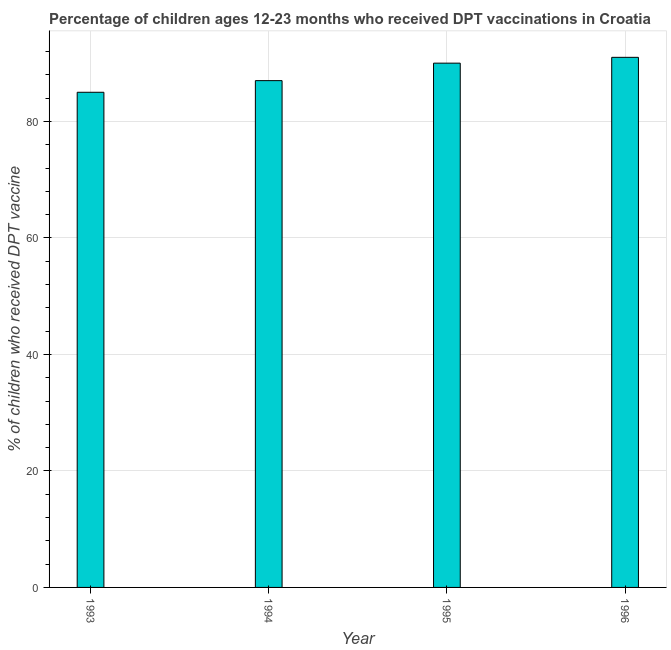Does the graph contain any zero values?
Your answer should be very brief. No. What is the title of the graph?
Provide a short and direct response. Percentage of children ages 12-23 months who received DPT vaccinations in Croatia. What is the label or title of the Y-axis?
Provide a short and direct response. % of children who received DPT vaccine. Across all years, what is the maximum percentage of children who received dpt vaccine?
Offer a terse response. 91. In which year was the percentage of children who received dpt vaccine maximum?
Offer a terse response. 1996. In which year was the percentage of children who received dpt vaccine minimum?
Ensure brevity in your answer.  1993. What is the sum of the percentage of children who received dpt vaccine?
Offer a terse response. 353. What is the average percentage of children who received dpt vaccine per year?
Give a very brief answer. 88. What is the median percentage of children who received dpt vaccine?
Provide a short and direct response. 88.5. In how many years, is the percentage of children who received dpt vaccine greater than 24 %?
Keep it short and to the point. 4. What is the ratio of the percentage of children who received dpt vaccine in 1993 to that in 1995?
Offer a terse response. 0.94. Is the percentage of children who received dpt vaccine in 1994 less than that in 1995?
Your answer should be compact. Yes. Is the difference between the percentage of children who received dpt vaccine in 1994 and 1995 greater than the difference between any two years?
Keep it short and to the point. No. What is the difference between the highest and the second highest percentage of children who received dpt vaccine?
Provide a short and direct response. 1. What is the difference between the highest and the lowest percentage of children who received dpt vaccine?
Provide a succinct answer. 6. Are all the bars in the graph horizontal?
Your answer should be very brief. No. What is the difference between two consecutive major ticks on the Y-axis?
Your answer should be very brief. 20. What is the % of children who received DPT vaccine in 1993?
Ensure brevity in your answer.  85. What is the % of children who received DPT vaccine of 1994?
Offer a very short reply. 87. What is the % of children who received DPT vaccine of 1995?
Make the answer very short. 90. What is the % of children who received DPT vaccine in 1996?
Keep it short and to the point. 91. What is the difference between the % of children who received DPT vaccine in 1993 and 1994?
Offer a terse response. -2. What is the ratio of the % of children who received DPT vaccine in 1993 to that in 1994?
Keep it short and to the point. 0.98. What is the ratio of the % of children who received DPT vaccine in 1993 to that in 1995?
Make the answer very short. 0.94. What is the ratio of the % of children who received DPT vaccine in 1993 to that in 1996?
Ensure brevity in your answer.  0.93. What is the ratio of the % of children who received DPT vaccine in 1994 to that in 1996?
Offer a very short reply. 0.96. 